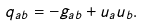Convert formula to latex. <formula><loc_0><loc_0><loc_500><loc_500>q _ { a b } = - g _ { a b } + u _ { a } u _ { b } .</formula> 